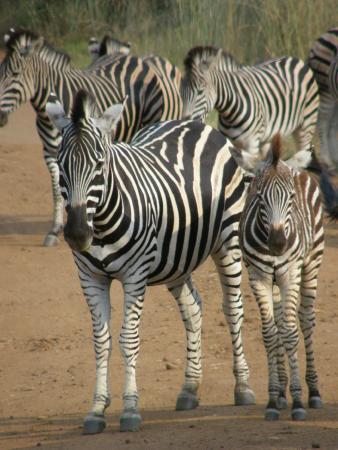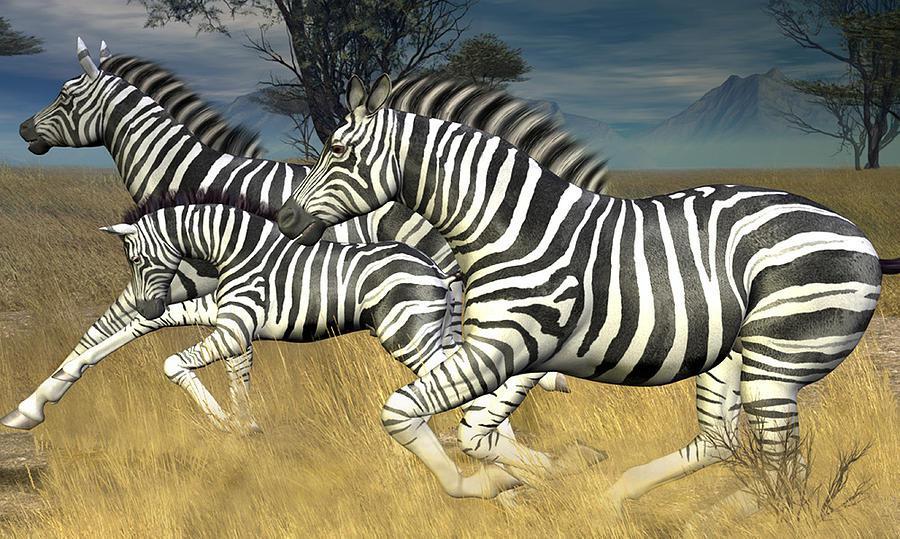The first image is the image on the left, the second image is the image on the right. For the images shown, is this caption "All the zebras are running." true? Answer yes or no. No. The first image is the image on the left, the second image is the image on the right. For the images shown, is this caption "Nine or fewer zebras are present." true? Answer yes or no. Yes. 